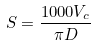Convert formula to latex. <formula><loc_0><loc_0><loc_500><loc_500>S = \frac { 1 0 0 0 V _ { c } } { \pi D }</formula> 